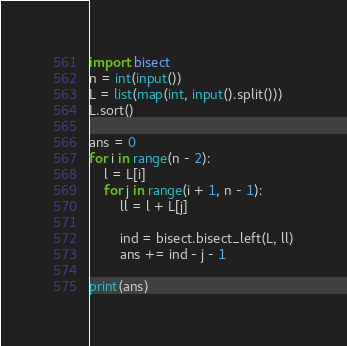Convert code to text. <code><loc_0><loc_0><loc_500><loc_500><_Python_>import bisect
n = int(input())
L = list(map(int, input().split()))
L.sort()

ans = 0
for i in range(n - 2):
    l = L[i]
    for j in range(i + 1, n - 1):
        ll = l + L[j]

        ind = bisect.bisect_left(L, ll)
        ans += ind - j - 1

print(ans)
</code> 